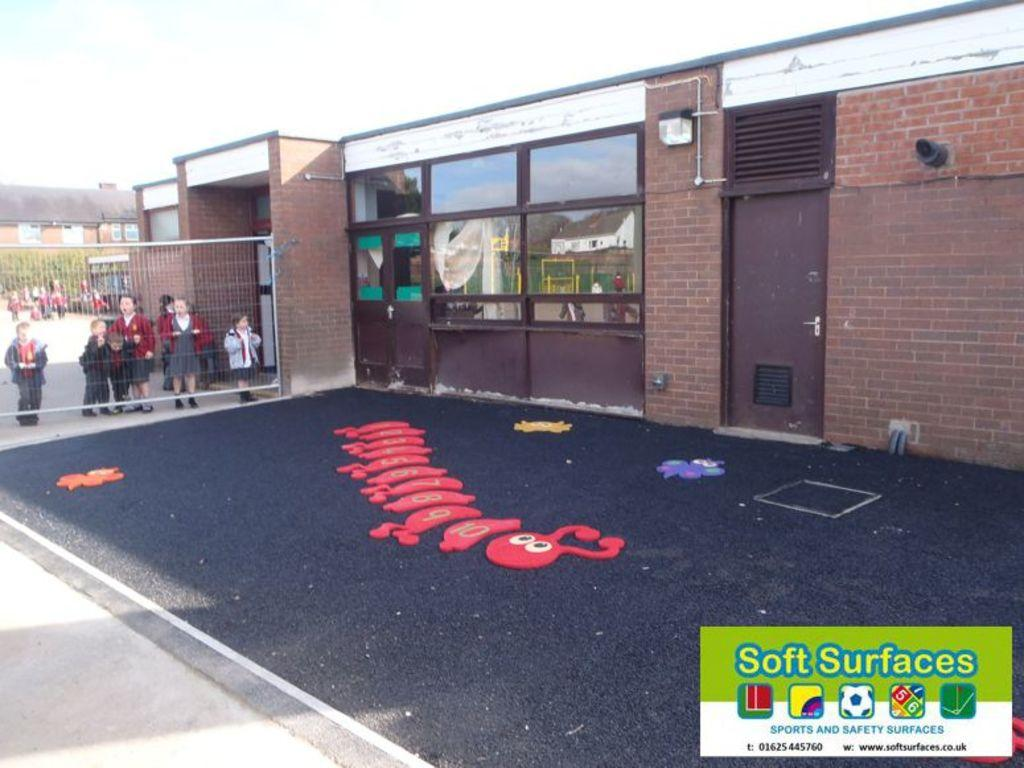What type of structures can be seen in the image? There are buildings in the image. What other natural elements are present in the image? There are trees in the image. Can you describe the children's location in the image? The children are standing behind a mesh in the image. What items are on the floor in the image? Toys are present on the floor in the image. What type of infrastructure can be seen in the image? Pipelines are visible in the image. What objects are in the image that might be used for drinking or eating? Glasses are in the image. What can be seen in the background of the image? The sky is visible in the background of the image. How many geese are flying in the image? There are no geese present in the image. What type of cream is being used to decorate the buildings in the image? There is no cream being used to decorate the buildings in the image. 